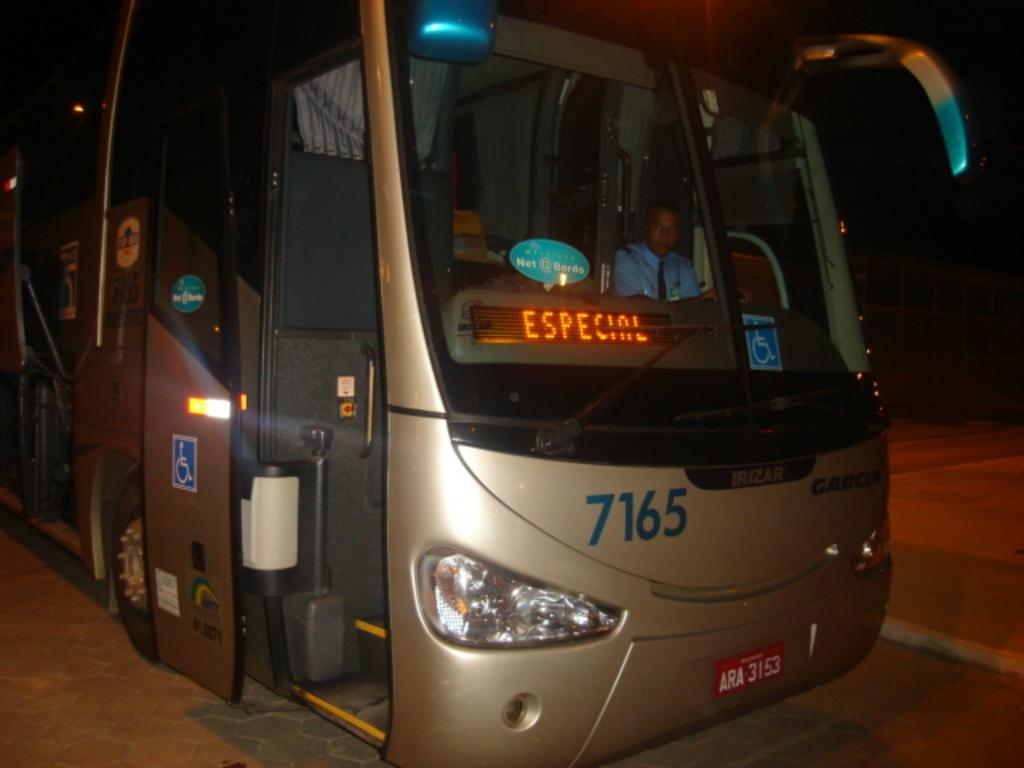What is the main subject of the image? The main subject of the image is a bus. Can you describe the person inside the bus? There is a man sitting inside the bus. What can be seen at the bottom of the image? There is a road visible at the bottom of the image. How many ants are crawling on the bus in the image? There are no ants present in the image; it features a bus with a man sitting inside. What type of growth can be seen on the bus in the image? There is no growth visible on the bus in the image. 